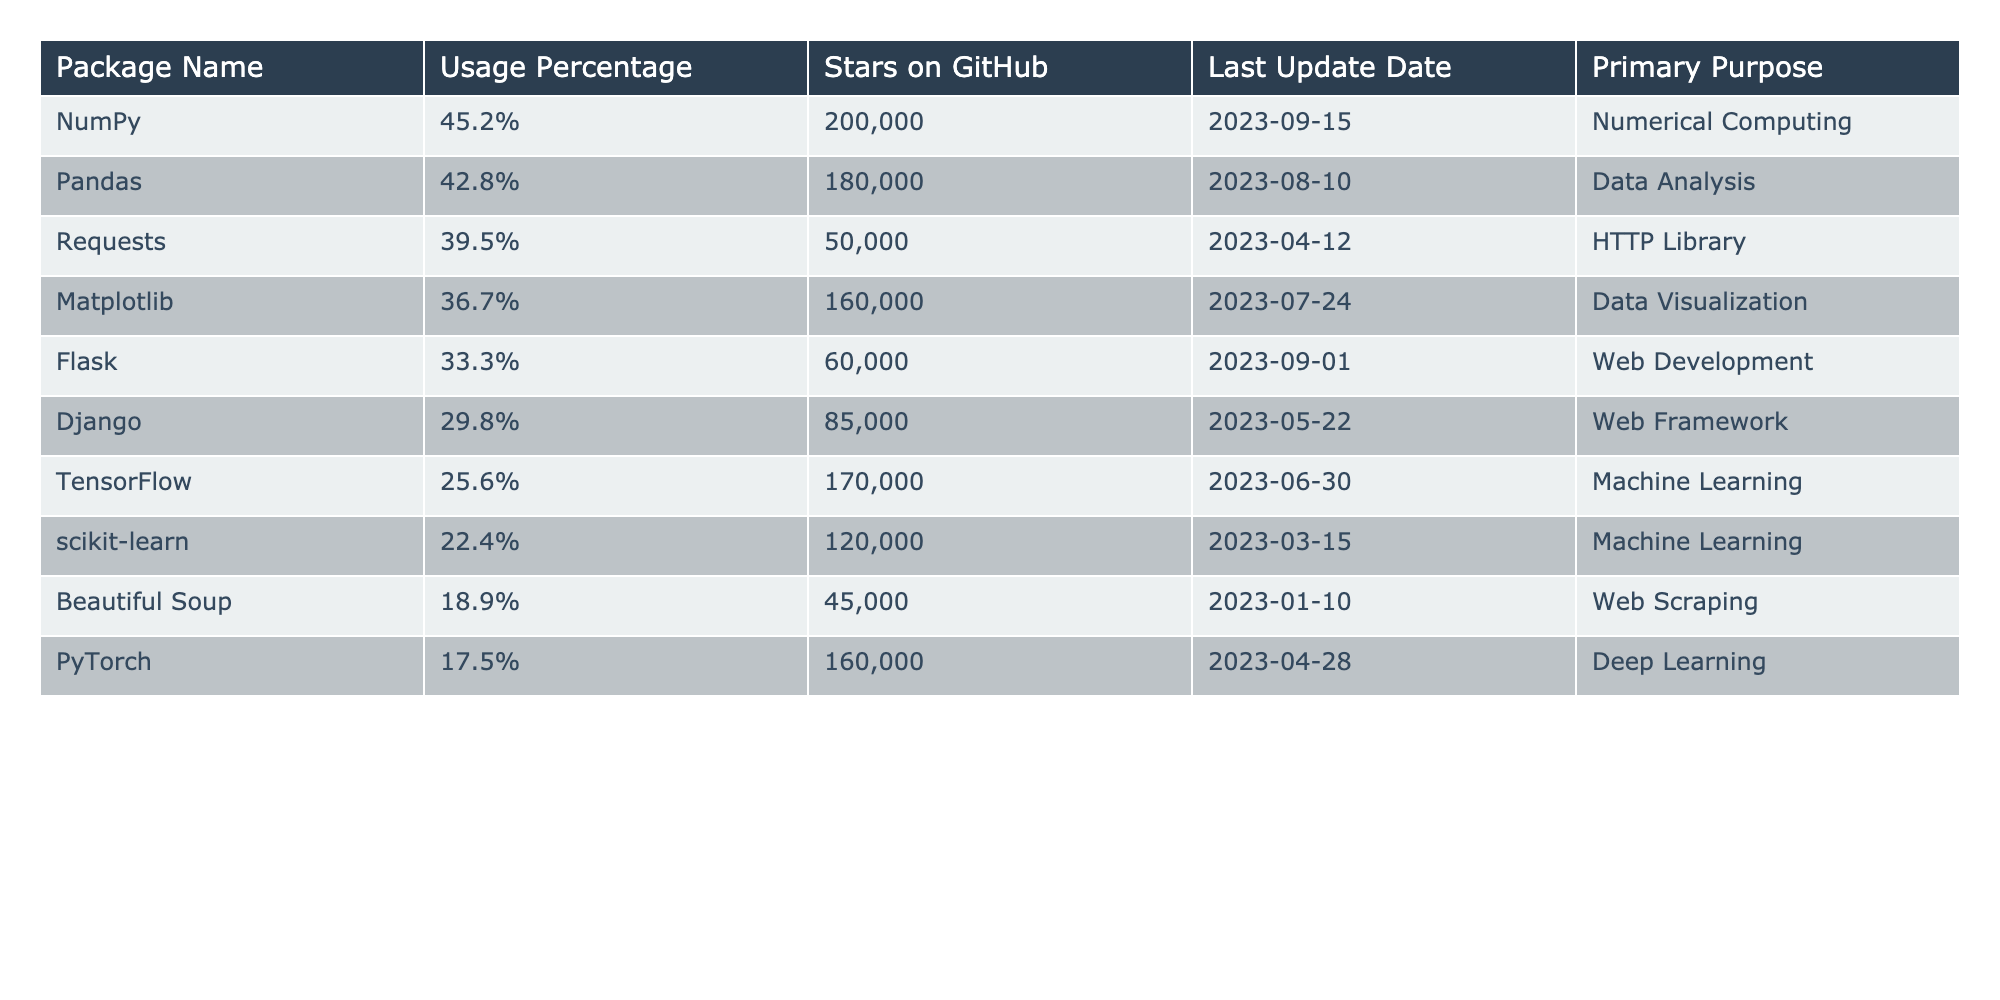What is the usage percentage of NumPy? The usage percentage column shows that NumPy has a value of 45.2%.
Answer: 45.2% Which package has the highest number of stars on GitHub? The stars on GitHub column indicates that NumPy has the highest stars, with a value of 200,000.
Answer: NumPy What is the primary purpose of Flask? The table states that the primary purpose of Flask is Web Development.
Answer: Web Development What is the average usage percentage of all the packages listed? To find the average, sum up all the usage percentages: (45.2 + 42.8 + 39.5 + 36.7 + 33.3 + 29.8 + 25.6 + 22.4 + 18.9 + 17.5) =  41.47%. Then, divide by the number of packages (10): 414.7 / 10 = 41.47%.
Answer: 41.47% Is the last update date of Pandas more recent than that of TensorFlow? The last update date for Pandas is 2023-08-10, while TensorFlow's is 2023-06-30. Since August is after June, Pandas is more recent.
Answer: Yes What package has the lowest usage percentage and what is that percentage? The table shows that Beautiful Soup has the lowest usage percentage of 18.9%.
Answer: Beautiful Soup, 18.9% If we combine the usage percentages of NumPy and Pandas, is that sum greater than 90%? The sum of usage percentages for NumPy (45.2%) and Pandas (42.8%) is 88%. Since 88% is less than 90%, the answer is no.
Answer: No How many packages have a primary purpose in Machine Learning? The table lists two packages with the primary purpose of Machine Learning: TensorFlow and scikit-learn.
Answer: 2 Which package was last updated most recently and what was the last update date? By checking the last update dates, Flask was updated last on 2023-09-01, making it the most recent update.
Answer: Flask, 2023-09-01 Are there more packages focused on Web Development or Data Analysis? There are two packages focused on Web Development (Flask, Django) and one focused on Data Analysis (Pandas); therefore, there are more packages for Web Development.
Answer: Web Development 